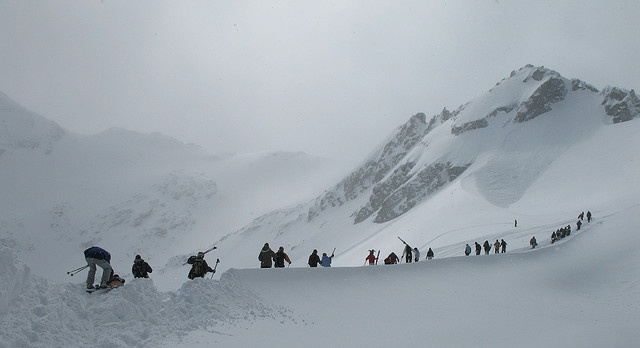Describe the objects in this image and their specific colors. I can see people in darkgray, black, and gray tones, people in darkgray, black, gray, and purple tones, people in darkgray, black, gray, and purple tones, people in darkgray, black, and gray tones, and people in darkgray, black, and gray tones in this image. 